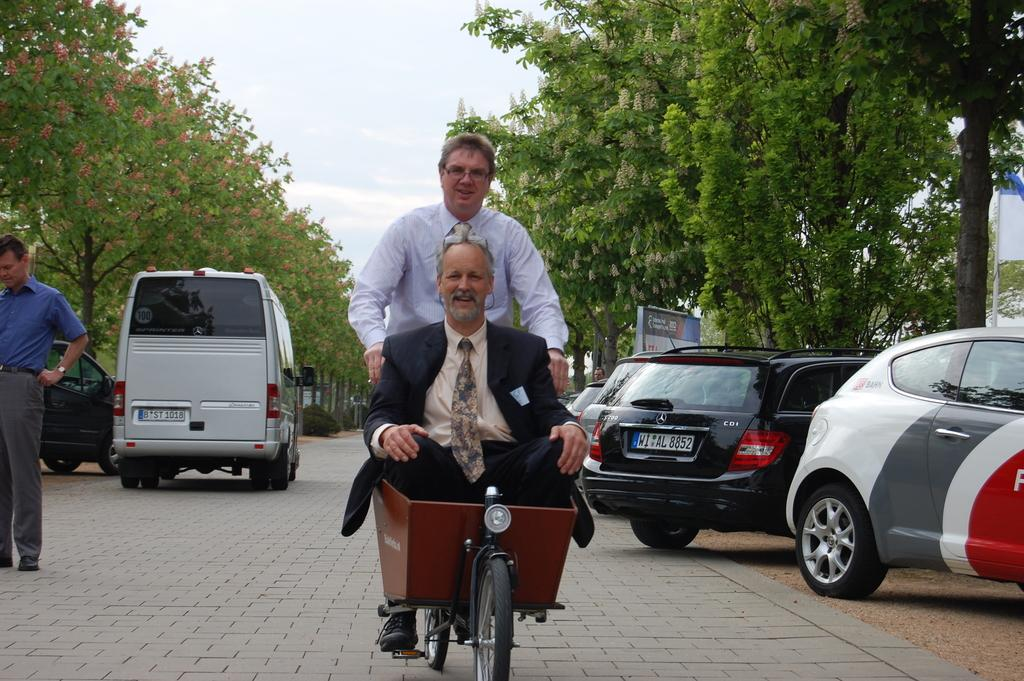How many people are on the vehicle in the image? There are two persons sitting on the vehicle. What is the third person doing in the image? There is a person riding the vehicle. What is the position of the fourth person in the image? There is a person standing. What can be seen on the road in the image? There are vehicles on the road. What is visible in the background of the image? Trees and the sky are visible in the background of the image. What type of action is the wind performing in the image? There is no wind present in the image, so it cannot perform any actions. What facial expression does the face on the vehicle have? There is no face present on the vehicle in the image. 